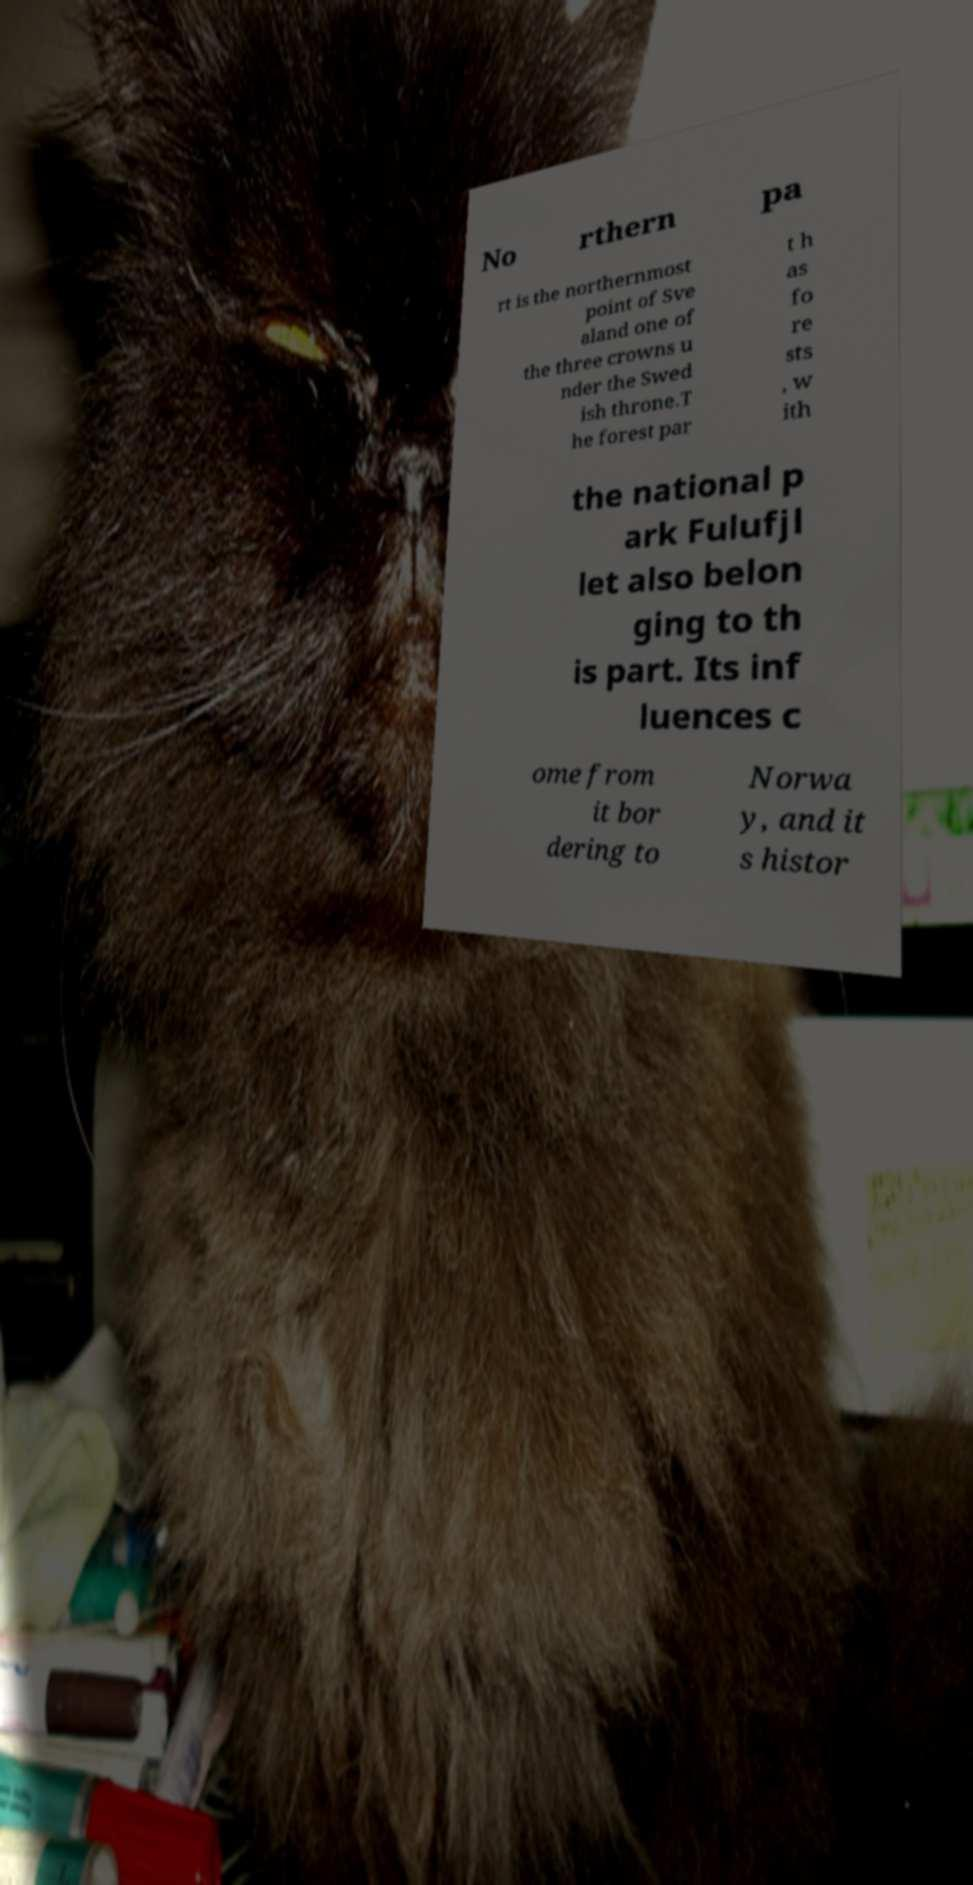For documentation purposes, I need the text within this image transcribed. Could you provide that? No rthern pa rt is the northernmost point of Sve aland one of the three crowns u nder the Swed ish throne.T he forest par t h as fo re sts , w ith the national p ark Fulufjl let also belon ging to th is part. Its inf luences c ome from it bor dering to Norwa y, and it s histor 